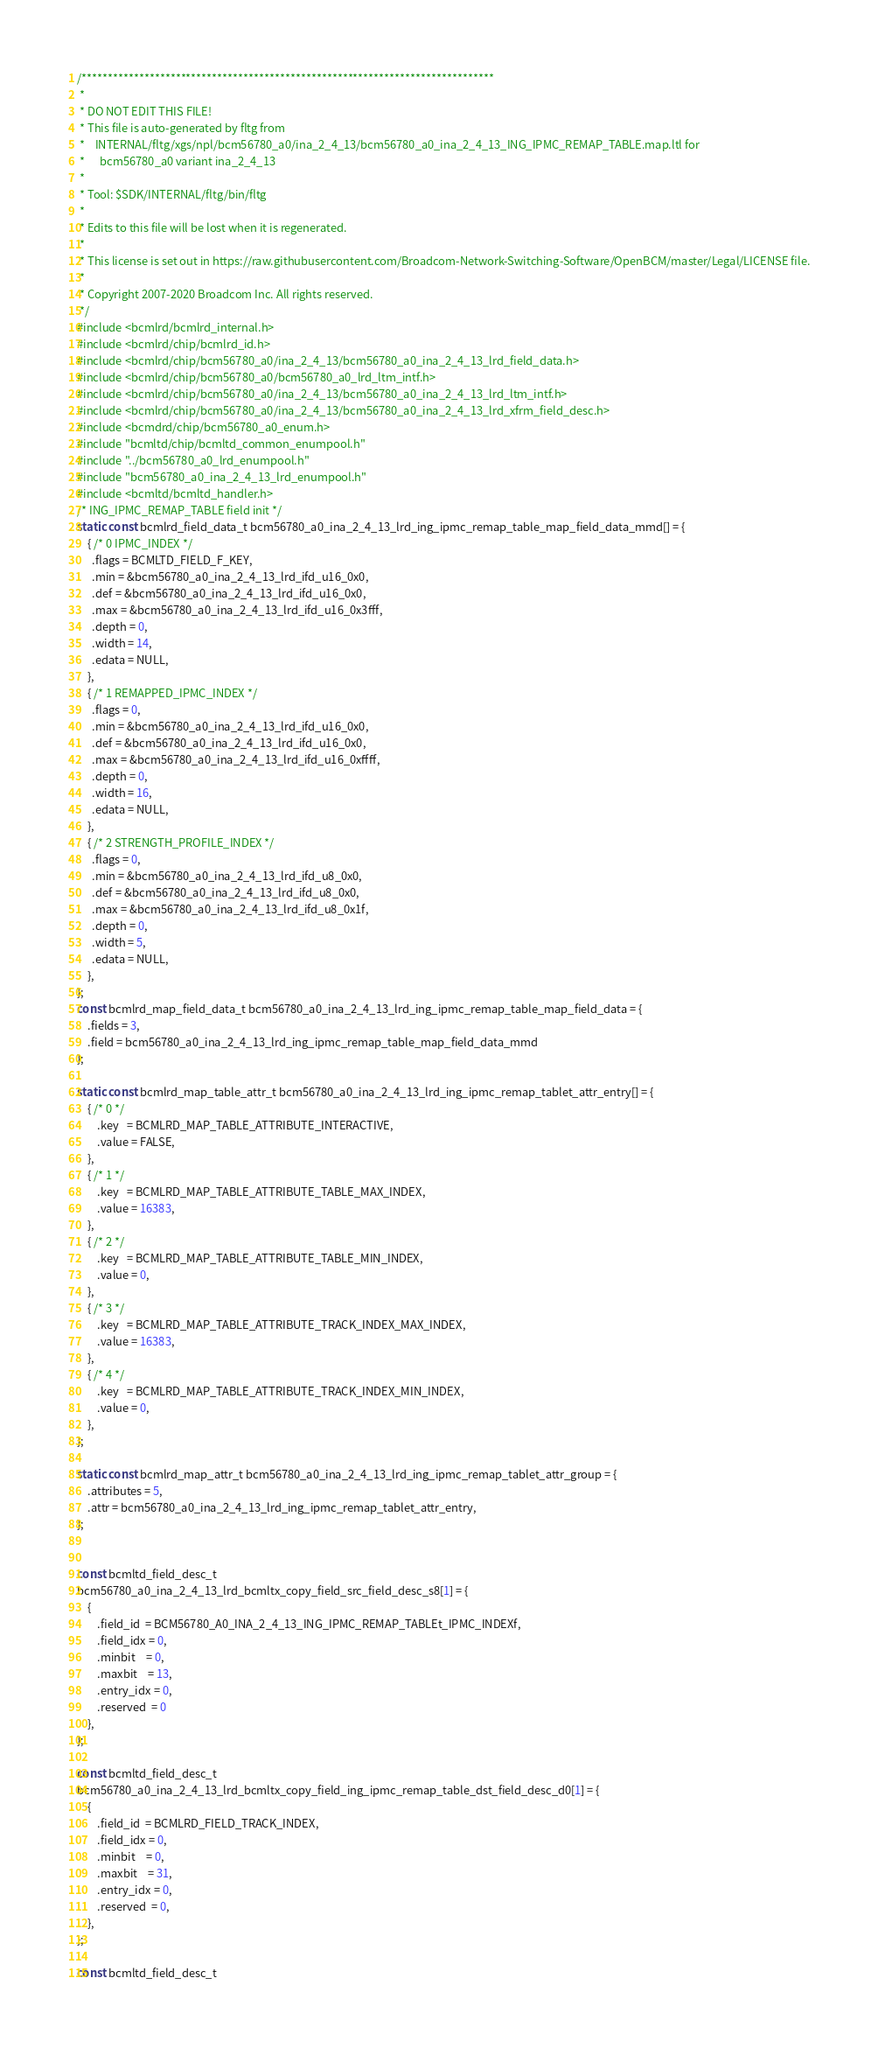<code> <loc_0><loc_0><loc_500><loc_500><_C_>/*******************************************************************************
 *
 * DO NOT EDIT THIS FILE!
 * This file is auto-generated by fltg from
 *    INTERNAL/fltg/xgs/npl/bcm56780_a0/ina_2_4_13/bcm56780_a0_ina_2_4_13_ING_IPMC_REMAP_TABLE.map.ltl for
 *      bcm56780_a0 variant ina_2_4_13
 *
 * Tool: $SDK/INTERNAL/fltg/bin/fltg
 *
 * Edits to this file will be lost when it is regenerated.
 *
 * This license is set out in https://raw.githubusercontent.com/Broadcom-Network-Switching-Software/OpenBCM/master/Legal/LICENSE file.
 * 
 * Copyright 2007-2020 Broadcom Inc. All rights reserved.
 */
#include <bcmlrd/bcmlrd_internal.h>
#include <bcmlrd/chip/bcmlrd_id.h>
#include <bcmlrd/chip/bcm56780_a0/ina_2_4_13/bcm56780_a0_ina_2_4_13_lrd_field_data.h>
#include <bcmlrd/chip/bcm56780_a0/bcm56780_a0_lrd_ltm_intf.h>
#include <bcmlrd/chip/bcm56780_a0/ina_2_4_13/bcm56780_a0_ina_2_4_13_lrd_ltm_intf.h>
#include <bcmlrd/chip/bcm56780_a0/ina_2_4_13/bcm56780_a0_ina_2_4_13_lrd_xfrm_field_desc.h>
#include <bcmdrd/chip/bcm56780_a0_enum.h>
#include "bcmltd/chip/bcmltd_common_enumpool.h"
#include "../bcm56780_a0_lrd_enumpool.h"
#include "bcm56780_a0_ina_2_4_13_lrd_enumpool.h"
#include <bcmltd/bcmltd_handler.h>
/* ING_IPMC_REMAP_TABLE field init */
static const bcmlrd_field_data_t bcm56780_a0_ina_2_4_13_lrd_ing_ipmc_remap_table_map_field_data_mmd[] = {
    { /* 0 IPMC_INDEX */
      .flags = BCMLTD_FIELD_F_KEY,
      .min = &bcm56780_a0_ina_2_4_13_lrd_ifd_u16_0x0,
      .def = &bcm56780_a0_ina_2_4_13_lrd_ifd_u16_0x0,
      .max = &bcm56780_a0_ina_2_4_13_lrd_ifd_u16_0x3fff,
      .depth = 0,
      .width = 14,
      .edata = NULL,
    },
    { /* 1 REMAPPED_IPMC_INDEX */
      .flags = 0,
      .min = &bcm56780_a0_ina_2_4_13_lrd_ifd_u16_0x0,
      .def = &bcm56780_a0_ina_2_4_13_lrd_ifd_u16_0x0,
      .max = &bcm56780_a0_ina_2_4_13_lrd_ifd_u16_0xffff,
      .depth = 0,
      .width = 16,
      .edata = NULL,
    },
    { /* 2 STRENGTH_PROFILE_INDEX */
      .flags = 0,
      .min = &bcm56780_a0_ina_2_4_13_lrd_ifd_u8_0x0,
      .def = &bcm56780_a0_ina_2_4_13_lrd_ifd_u8_0x0,
      .max = &bcm56780_a0_ina_2_4_13_lrd_ifd_u8_0x1f,
      .depth = 0,
      .width = 5,
      .edata = NULL,
    },
};
const bcmlrd_map_field_data_t bcm56780_a0_ina_2_4_13_lrd_ing_ipmc_remap_table_map_field_data = {
    .fields = 3,
    .field = bcm56780_a0_ina_2_4_13_lrd_ing_ipmc_remap_table_map_field_data_mmd
};

static const bcmlrd_map_table_attr_t bcm56780_a0_ina_2_4_13_lrd_ing_ipmc_remap_tablet_attr_entry[] = {
    { /* 0 */
        .key   = BCMLRD_MAP_TABLE_ATTRIBUTE_INTERACTIVE,
        .value = FALSE,
    },
    { /* 1 */
        .key   = BCMLRD_MAP_TABLE_ATTRIBUTE_TABLE_MAX_INDEX,
        .value = 16383,
    },
    { /* 2 */
        .key   = BCMLRD_MAP_TABLE_ATTRIBUTE_TABLE_MIN_INDEX,
        .value = 0,
    },
    { /* 3 */
        .key   = BCMLRD_MAP_TABLE_ATTRIBUTE_TRACK_INDEX_MAX_INDEX,
        .value = 16383,
    },
    { /* 4 */
        .key   = BCMLRD_MAP_TABLE_ATTRIBUTE_TRACK_INDEX_MIN_INDEX,
        .value = 0,
    },
};

static const bcmlrd_map_attr_t bcm56780_a0_ina_2_4_13_lrd_ing_ipmc_remap_tablet_attr_group = {
    .attributes = 5,
    .attr = bcm56780_a0_ina_2_4_13_lrd_ing_ipmc_remap_tablet_attr_entry,
};


const bcmltd_field_desc_t
bcm56780_a0_ina_2_4_13_lrd_bcmltx_copy_field_src_field_desc_s8[1] = {
    {
        .field_id  = BCM56780_A0_INA_2_4_13_ING_IPMC_REMAP_TABLEt_IPMC_INDEXf,
        .field_idx = 0,
        .minbit    = 0,
        .maxbit    = 13,
        .entry_idx = 0,
        .reserved  = 0
    },
};

const bcmltd_field_desc_t
bcm56780_a0_ina_2_4_13_lrd_bcmltx_copy_field_ing_ipmc_remap_table_dst_field_desc_d0[1] = {
    {
        .field_id  = BCMLRD_FIELD_TRACK_INDEX,
        .field_idx = 0,
        .minbit    = 0,
        .maxbit    = 31,
        .entry_idx = 0,
        .reserved  = 0,
    },
};

const bcmltd_field_desc_t</code> 